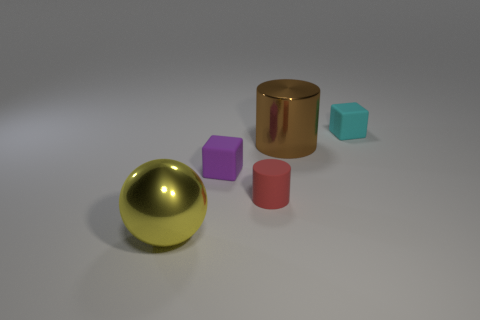There is a big shiny thing left of the metallic thing that is right of the small red rubber cylinder; are there any big metal spheres on the right side of it?
Ensure brevity in your answer.  No. Do the tiny rubber cube on the left side of the small red thing and the sphere have the same color?
Provide a succinct answer. No. What number of cubes are either yellow metal things or small objects?
Make the answer very short. 2. There is a metallic object that is to the right of the metal thing that is on the left side of the brown shiny cylinder; what shape is it?
Provide a short and direct response. Cylinder. What is the size of the block in front of the big object behind the big shiny thing that is to the left of the brown cylinder?
Provide a succinct answer. Small. Do the cyan matte cube and the red thing have the same size?
Provide a short and direct response. Yes. How many objects are red things or red matte blocks?
Your response must be concise. 1. What is the size of the shiny thing right of the metallic object that is to the left of the small cylinder?
Offer a terse response. Large. The cyan rubber block is what size?
Give a very brief answer. Small. There is a matte object that is both behind the red matte cylinder and left of the tiny cyan cube; what is its shape?
Your response must be concise. Cube. 